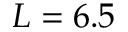<formula> <loc_0><loc_0><loc_500><loc_500>L = 6 . 5</formula> 